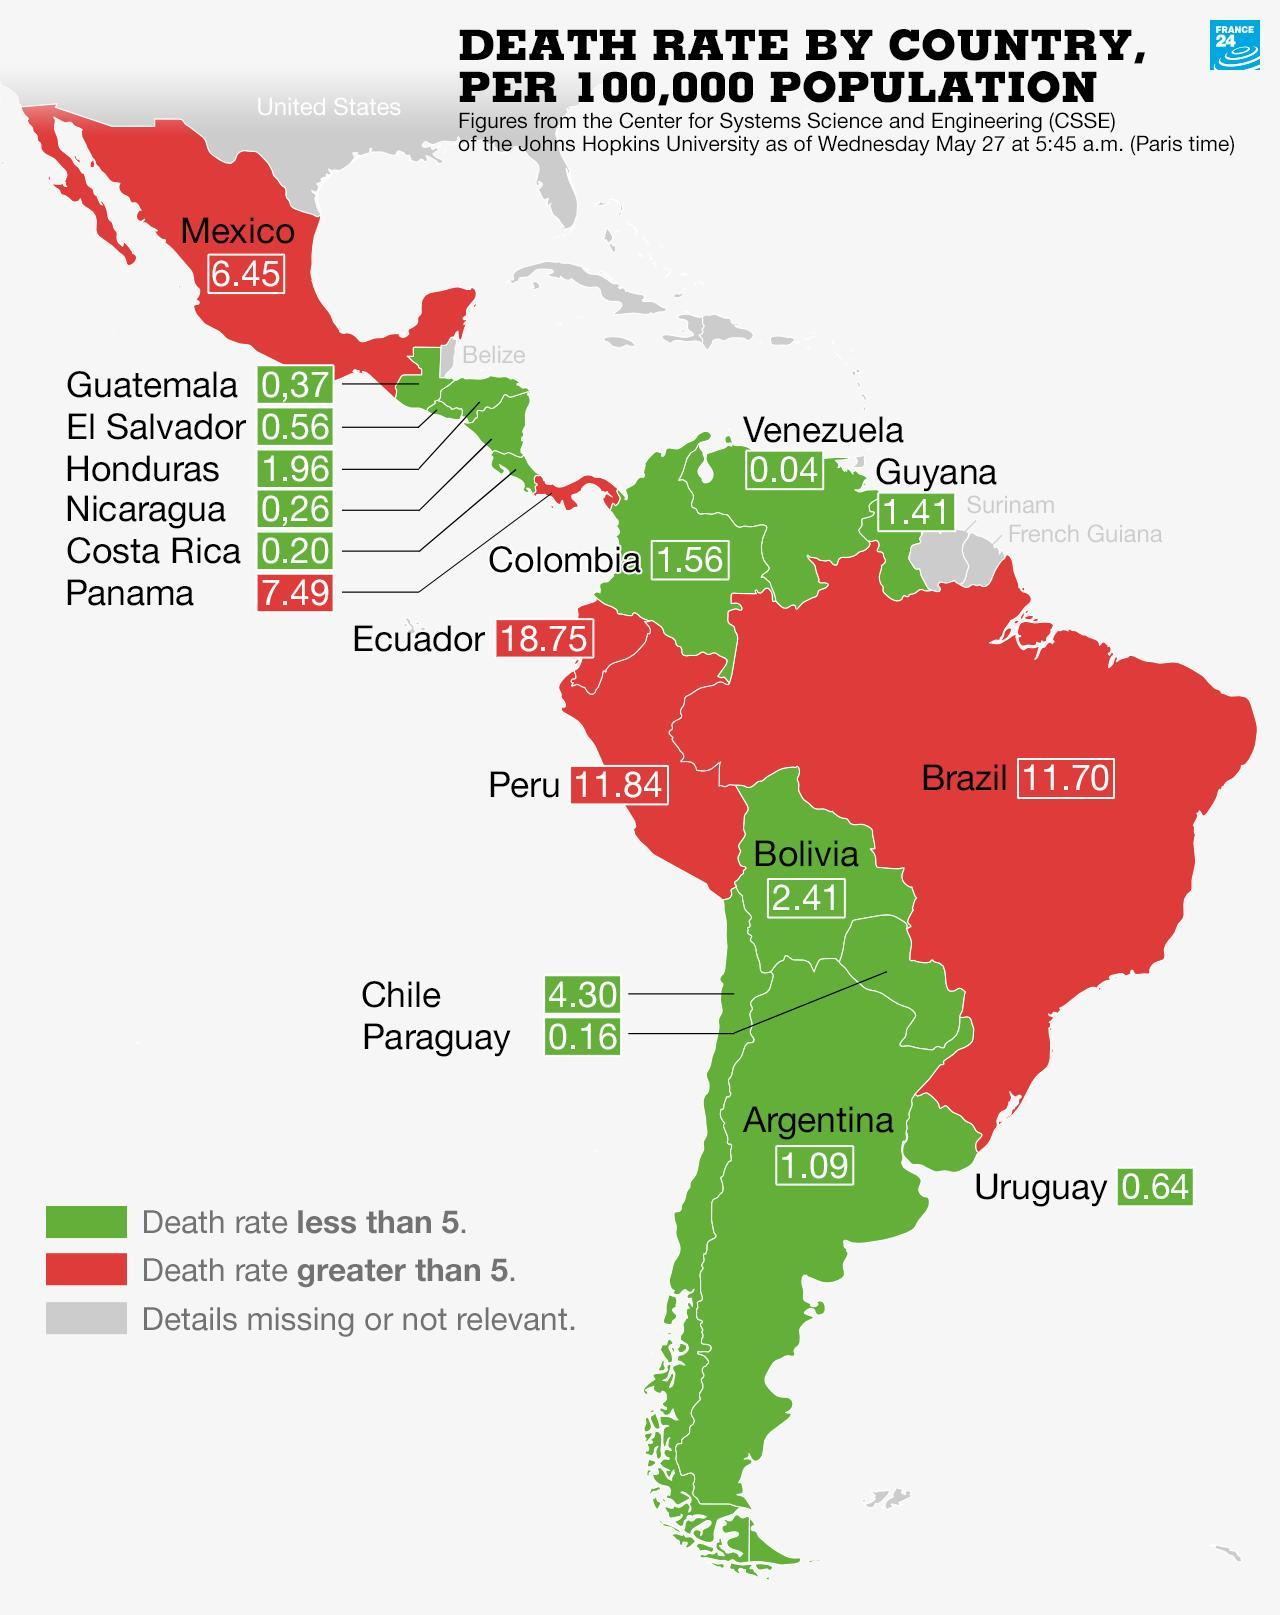How many countries have death rate less than 5?
Answer the question with a short phrase. 13 By what colour is countries with death rate less than 5 shown- red, green or grey? green Which country has the lowest death rate recorded? Venezuela What is the death rate in Surinam? Details missing or not relevant. What does countries marked in red denote? Death rate greater than 5. Which country has highest death rate? Ecuador 